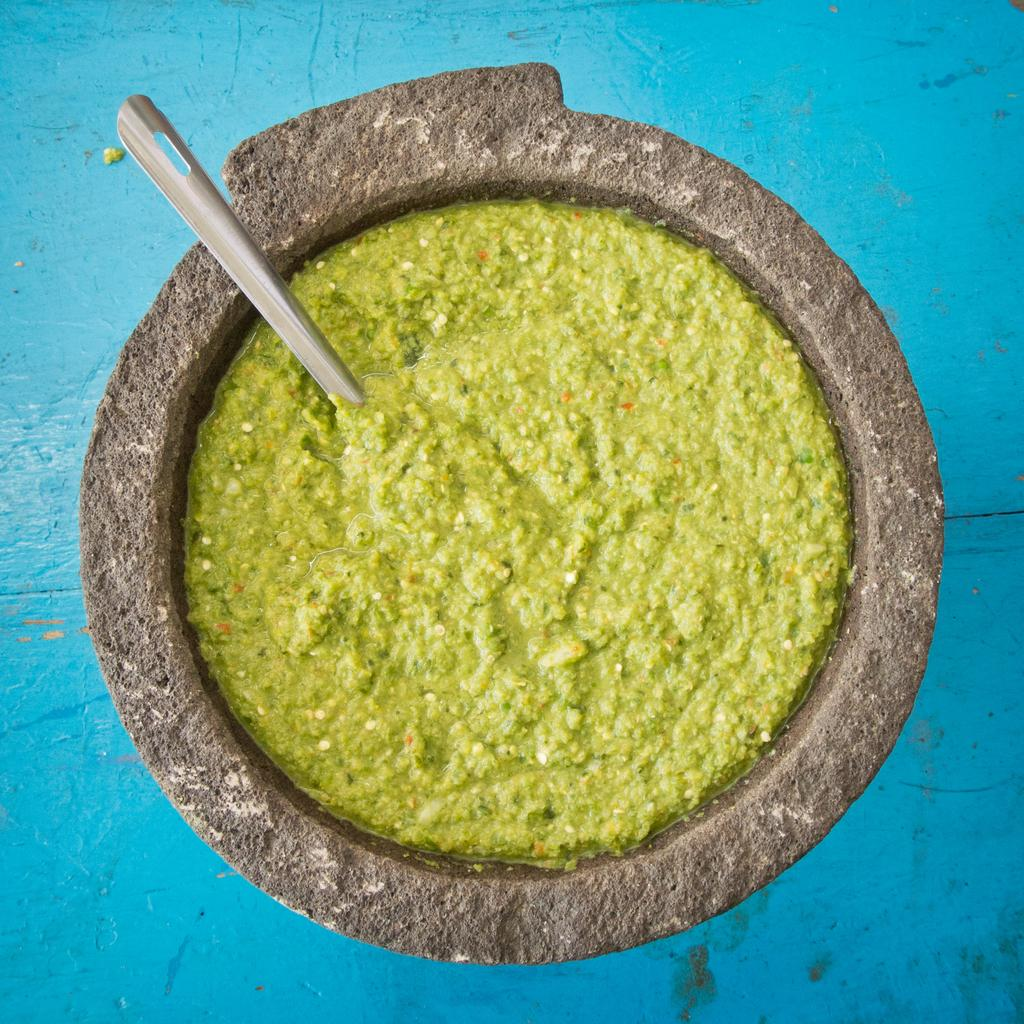What type of bowl is in the image? There is a stone bowl in the image. Where is the bowl located? The bowl is on a surface. What is inside the bowl? There is a spoon and food in the bowl. What is the scene like in the stomach of the person who ate the food from the bowl? There is no information about a person eating the food or their stomach in the image, so we cannot answer that question. 